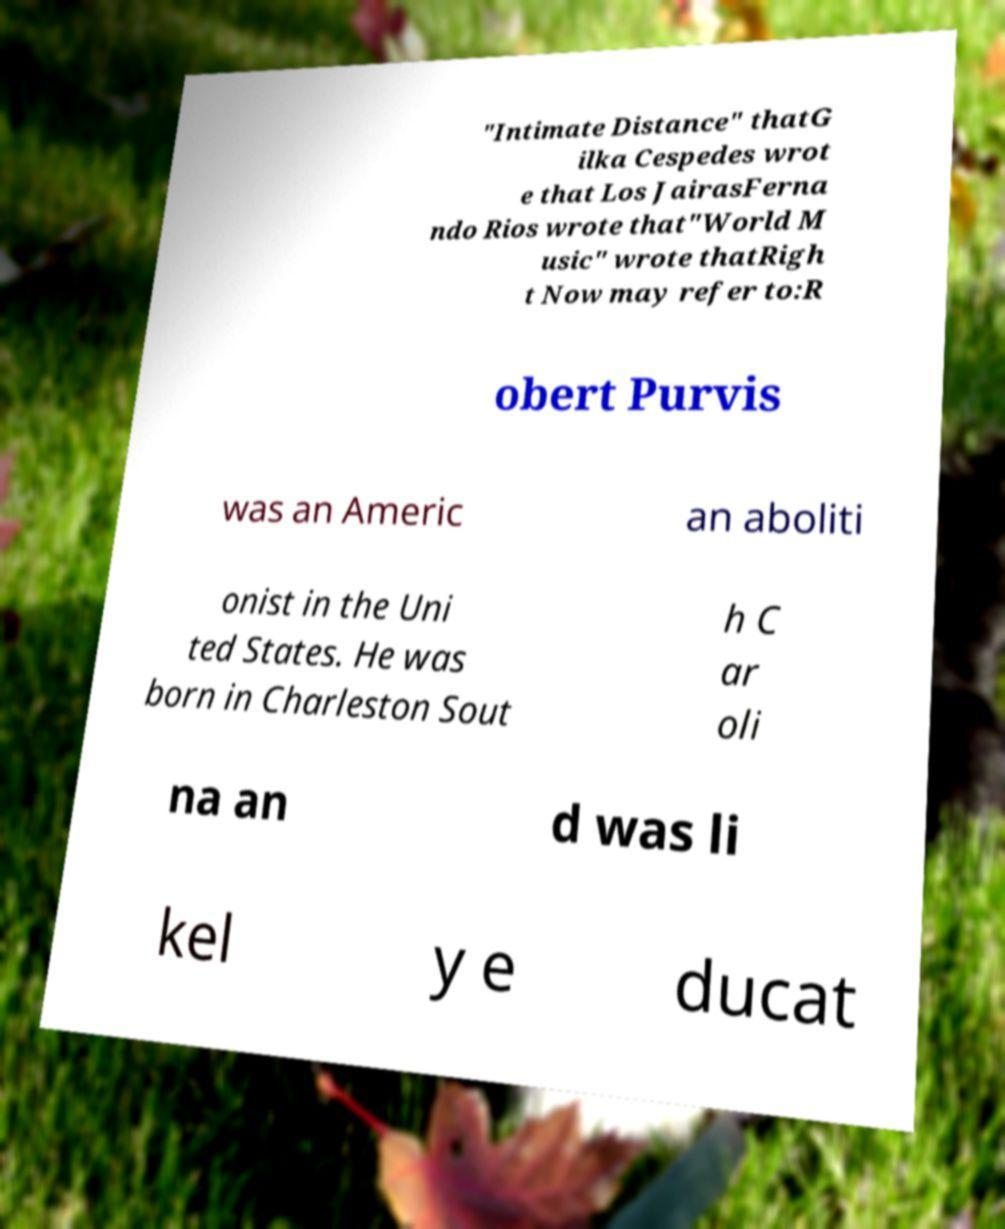Can you read and provide the text displayed in the image?This photo seems to have some interesting text. Can you extract and type it out for me? "Intimate Distance" thatG ilka Cespedes wrot e that Los JairasFerna ndo Rios wrote that"World M usic" wrote thatRigh t Now may refer to:R obert Purvis was an Americ an aboliti onist in the Uni ted States. He was born in Charleston Sout h C ar oli na an d was li kel y e ducat 